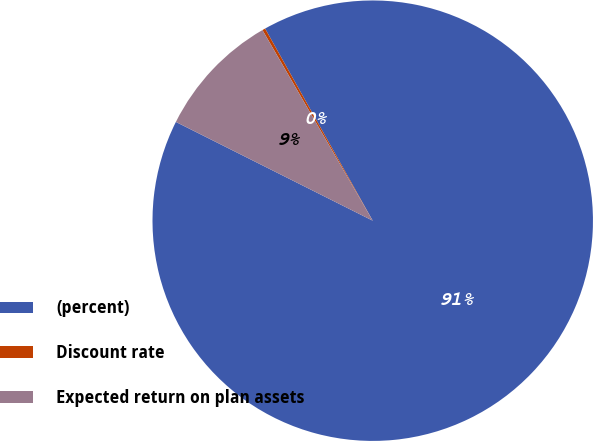Convert chart to OTSL. <chart><loc_0><loc_0><loc_500><loc_500><pie_chart><fcel>(percent)<fcel>Discount rate<fcel>Expected return on plan assets<nl><fcel>90.53%<fcel>0.22%<fcel>9.25%<nl></chart> 